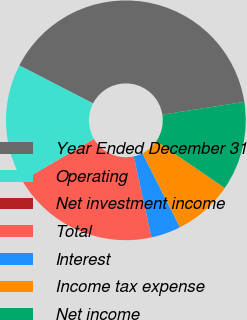<chart> <loc_0><loc_0><loc_500><loc_500><pie_chart><fcel>Year Ended December 31<fcel>Operating<fcel>Net investment income<fcel>Total<fcel>Interest<fcel>Income tax expense<fcel>Net income<nl><fcel>39.97%<fcel>16.0%<fcel>0.01%<fcel>19.99%<fcel>4.01%<fcel>8.01%<fcel>12.0%<nl></chart> 